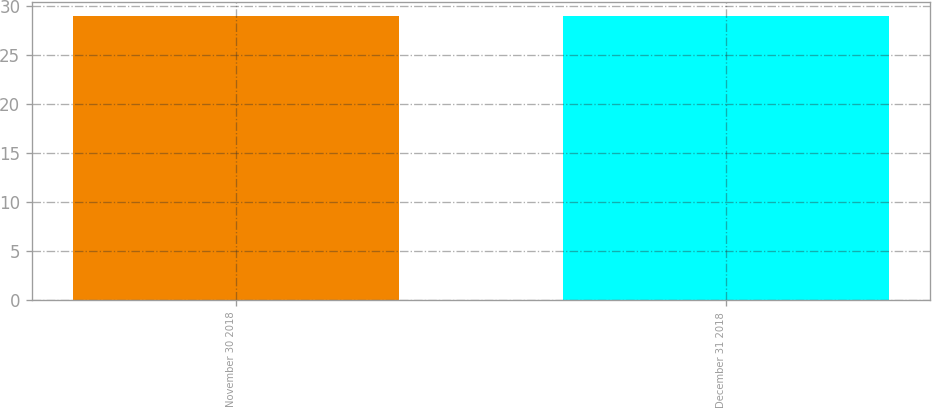<chart> <loc_0><loc_0><loc_500><loc_500><bar_chart><fcel>November 30 2018<fcel>December 31 2018<nl><fcel>28.96<fcel>28.91<nl></chart> 